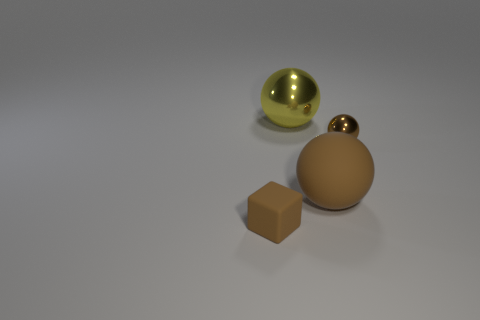Add 1 big objects. How many objects exist? 5 Subtract all blocks. How many objects are left? 3 Subtract 0 brown cylinders. How many objects are left? 4 Subtract all cyan things. Subtract all large shiny spheres. How many objects are left? 3 Add 1 tiny spheres. How many tiny spheres are left? 2 Add 3 brown cubes. How many brown cubes exist? 4 